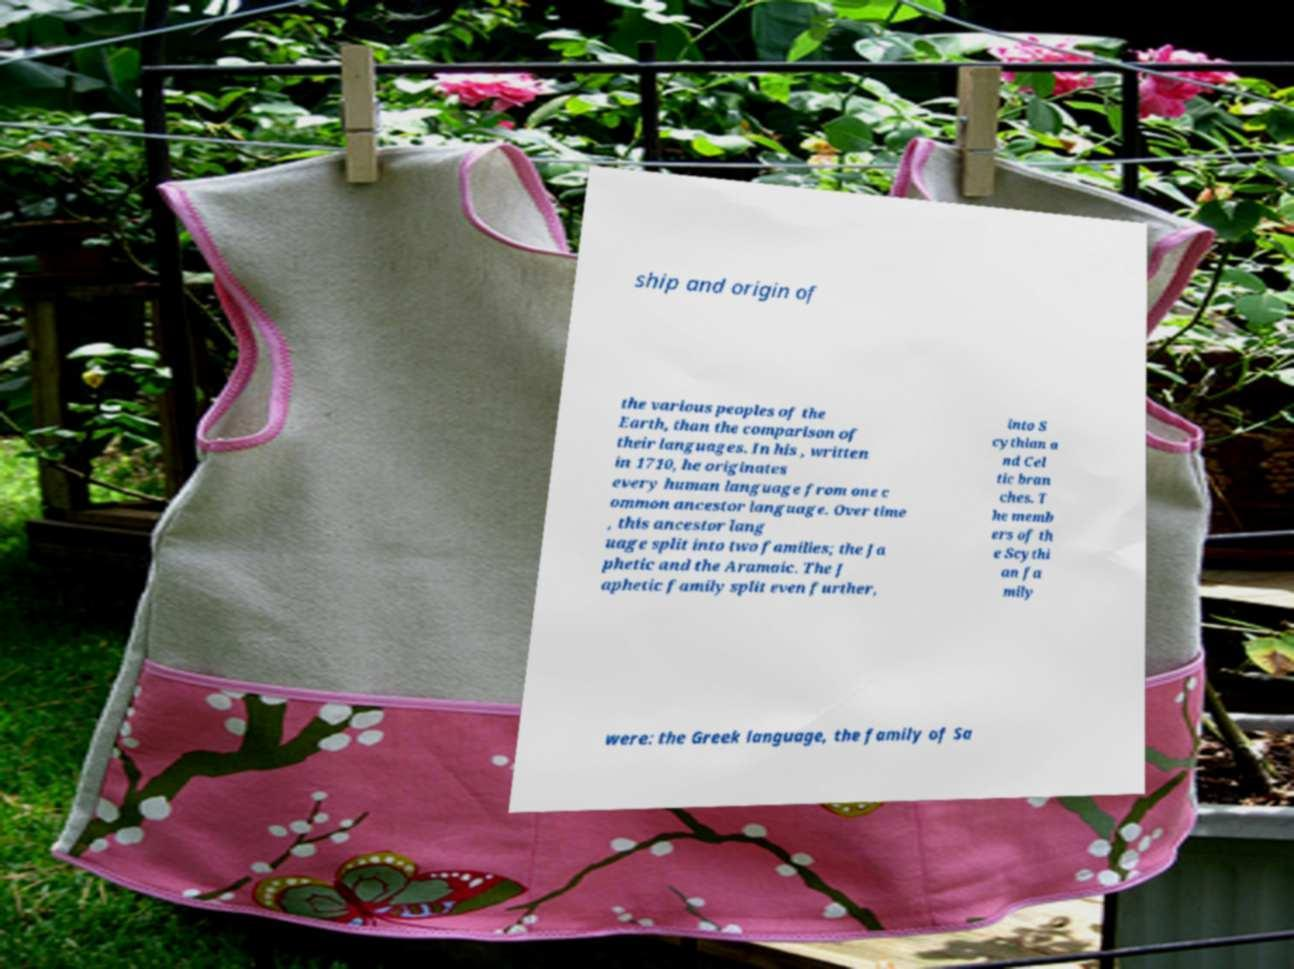Can you accurately transcribe the text from the provided image for me? ship and origin of the various peoples of the Earth, than the comparison of their languages. In his , written in 1710, he originates every human language from one c ommon ancestor language. Over time , this ancestor lang uage split into two families; the Ja phetic and the Aramaic. The J aphetic family split even further, into S cythian a nd Cel tic bran ches. T he memb ers of th e Scythi an fa mily were: the Greek language, the family of Sa 